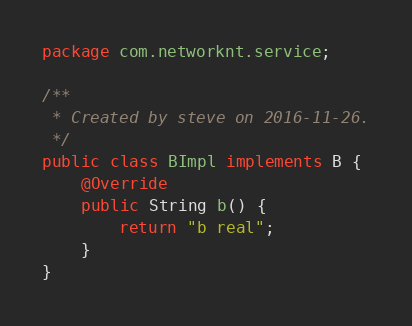Convert code to text. <code><loc_0><loc_0><loc_500><loc_500><_Java_>package com.networknt.service;

/**
 * Created by steve on 2016-11-26.
 */
public class BImpl implements B {
    @Override
    public String b() {
        return "b real";
    }
}
</code> 